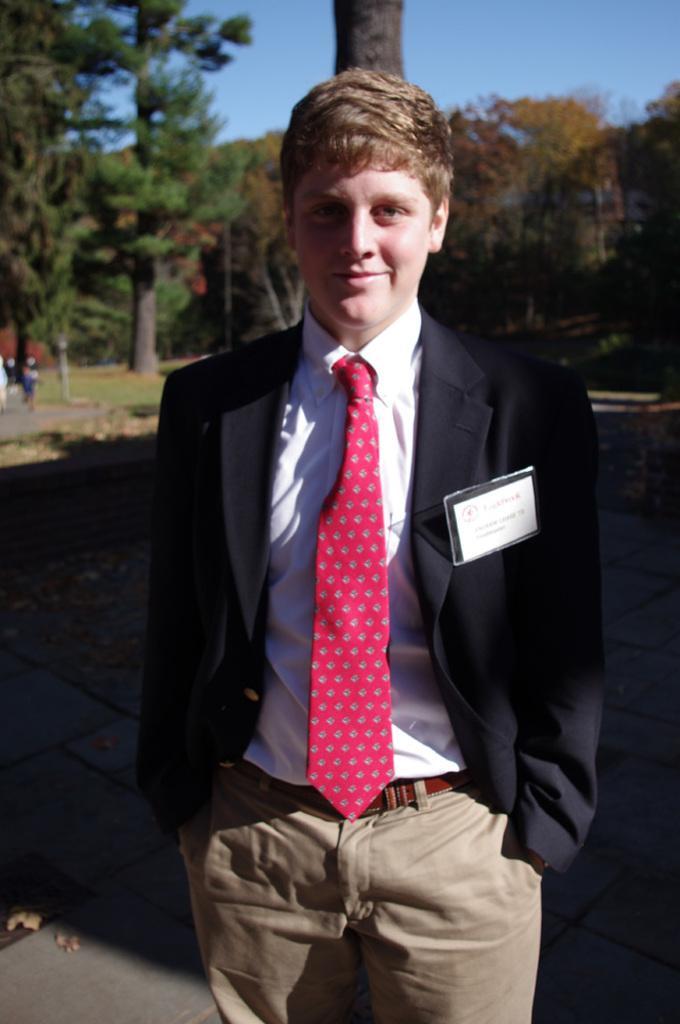How would you summarize this image in a sentence or two? In this image I can see a man is standing in the front and I can see he is wearing white shirt, red tie, black blazer and pant. I can also see a white colour thing on his right side and on it I can see something is written. In the background I can see number of trees, shadows and the sky. 